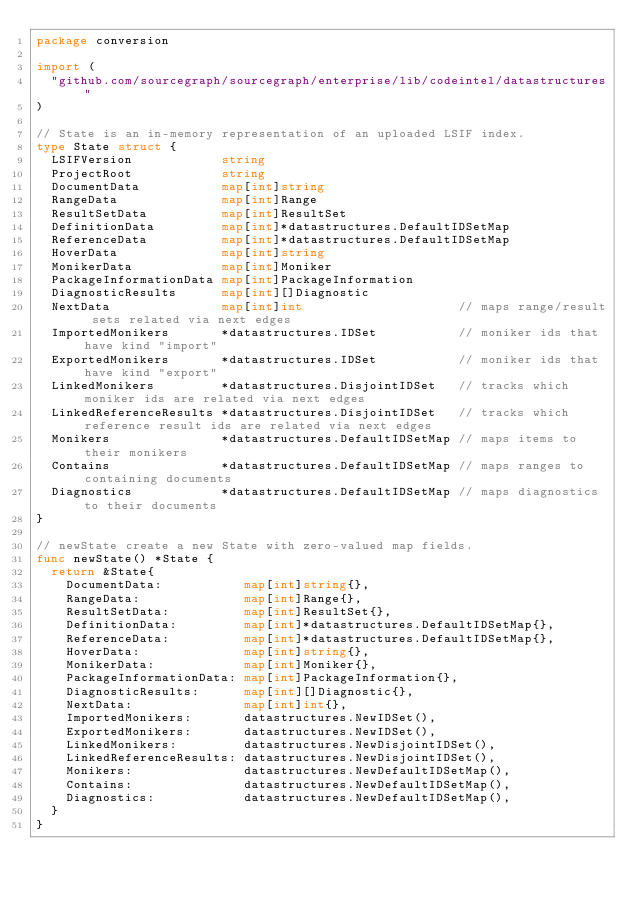Convert code to text. <code><loc_0><loc_0><loc_500><loc_500><_Go_>package conversion

import (
	"github.com/sourcegraph/sourcegraph/enterprise/lib/codeintel/datastructures"
)

// State is an in-memory representation of an uploaded LSIF index.
type State struct {
	LSIFVersion            string
	ProjectRoot            string
	DocumentData           map[int]string
	RangeData              map[int]Range
	ResultSetData          map[int]ResultSet
	DefinitionData         map[int]*datastructures.DefaultIDSetMap
	ReferenceData          map[int]*datastructures.DefaultIDSetMap
	HoverData              map[int]string
	MonikerData            map[int]Moniker
	PackageInformationData map[int]PackageInformation
	DiagnosticResults      map[int][]Diagnostic
	NextData               map[int]int                     // maps range/result sets related via next edges
	ImportedMonikers       *datastructures.IDSet           // moniker ids that have kind "import"
	ExportedMonikers       *datastructures.IDSet           // moniker ids that have kind "export"
	LinkedMonikers         *datastructures.DisjointIDSet   // tracks which moniker ids are related via next edges
	LinkedReferenceResults *datastructures.DisjointIDSet   // tracks which reference result ids are related via next edges
	Monikers               *datastructures.DefaultIDSetMap // maps items to their monikers
	Contains               *datastructures.DefaultIDSetMap // maps ranges to containing documents
	Diagnostics            *datastructures.DefaultIDSetMap // maps diagnostics to their documents
}

// newState create a new State with zero-valued map fields.
func newState() *State {
	return &State{
		DocumentData:           map[int]string{},
		RangeData:              map[int]Range{},
		ResultSetData:          map[int]ResultSet{},
		DefinitionData:         map[int]*datastructures.DefaultIDSetMap{},
		ReferenceData:          map[int]*datastructures.DefaultIDSetMap{},
		HoverData:              map[int]string{},
		MonikerData:            map[int]Moniker{},
		PackageInformationData: map[int]PackageInformation{},
		DiagnosticResults:      map[int][]Diagnostic{},
		NextData:               map[int]int{},
		ImportedMonikers:       datastructures.NewIDSet(),
		ExportedMonikers:       datastructures.NewIDSet(),
		LinkedMonikers:         datastructures.NewDisjointIDSet(),
		LinkedReferenceResults: datastructures.NewDisjointIDSet(),
		Monikers:               datastructures.NewDefaultIDSetMap(),
		Contains:               datastructures.NewDefaultIDSetMap(),
		Diagnostics:            datastructures.NewDefaultIDSetMap(),
	}
}
</code> 